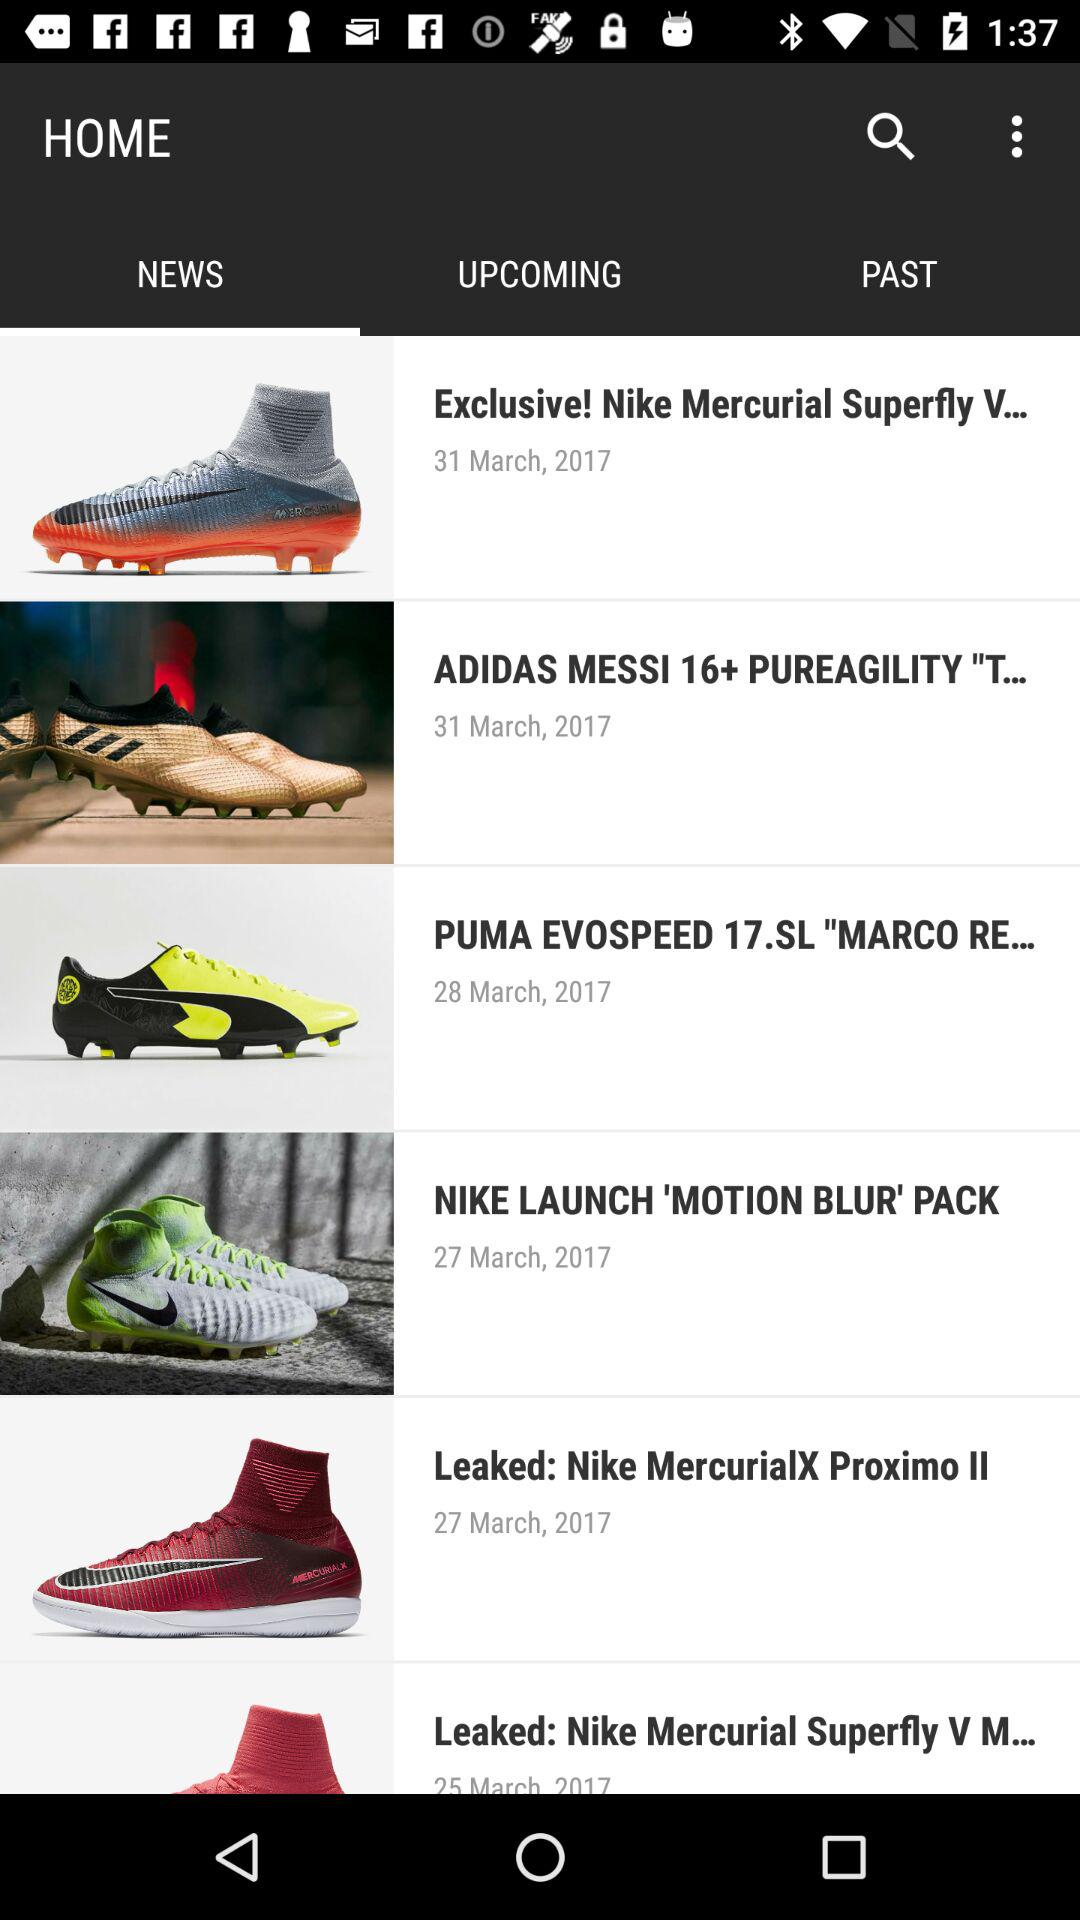On what date was "NIKE LAUNCH 'MOTION BLUR' PACK" posted? "NIKE LAUNCH 'MOTION BLUR' PACK" was posted on 27 March, 2017. 